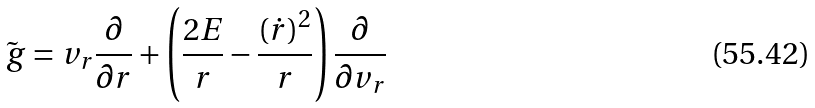Convert formula to latex. <formula><loc_0><loc_0><loc_500><loc_500>\tilde { \ g } = v _ { r } \frac { \partial } { \partial r } + \left ( \frac { 2 E } { r } - \frac { ( \dot { r } ) ^ { 2 } } { r } \right ) \frac { \partial } { \partial v _ { r } }</formula> 